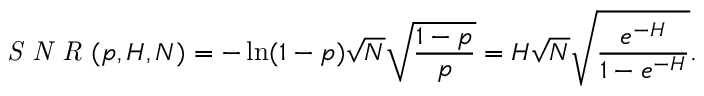<formula> <loc_0><loc_0><loc_500><loc_500>S N R ( p , H , N ) = - \ln ( 1 - p ) \sqrt { N } \sqrt { \frac { 1 - p } { p } } = H \sqrt { N } \sqrt { \frac { e ^ { - H } } { 1 - e ^ { - H } } } .</formula> 